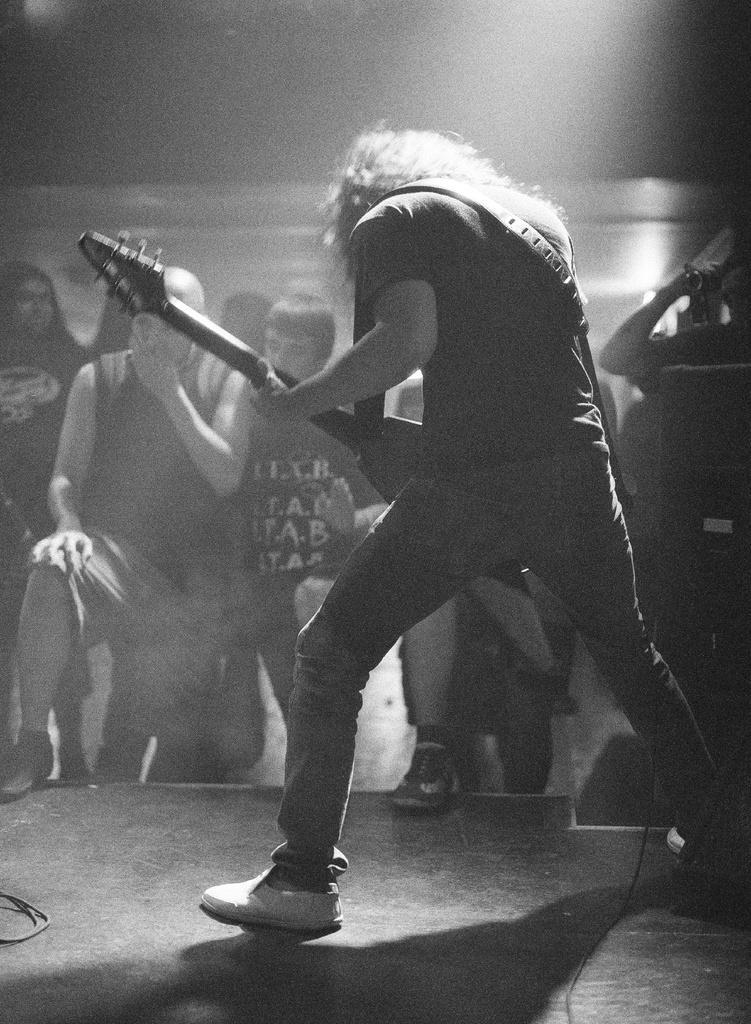Can you describe this image briefly? In this picture a guy is playing a guitar and in the background there are many spectators viewing him. 